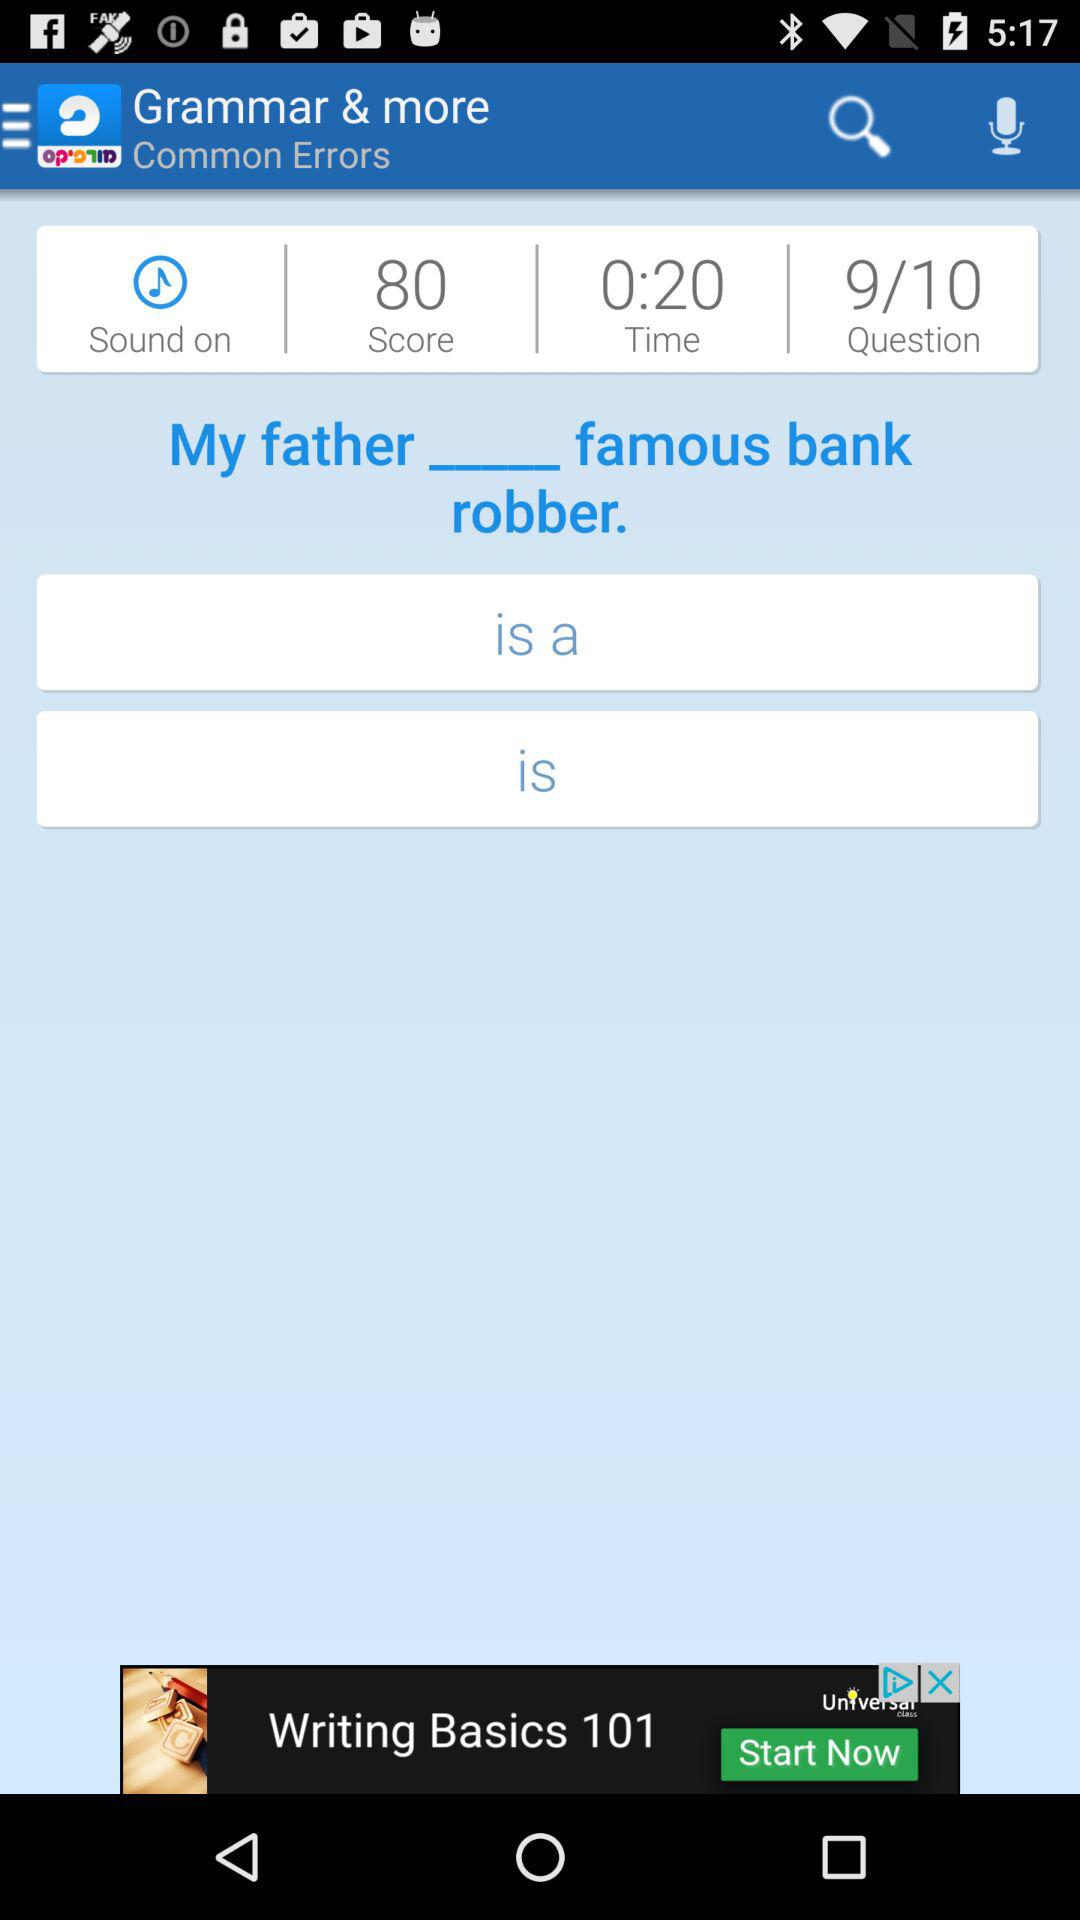What is the score? The score is 80. 